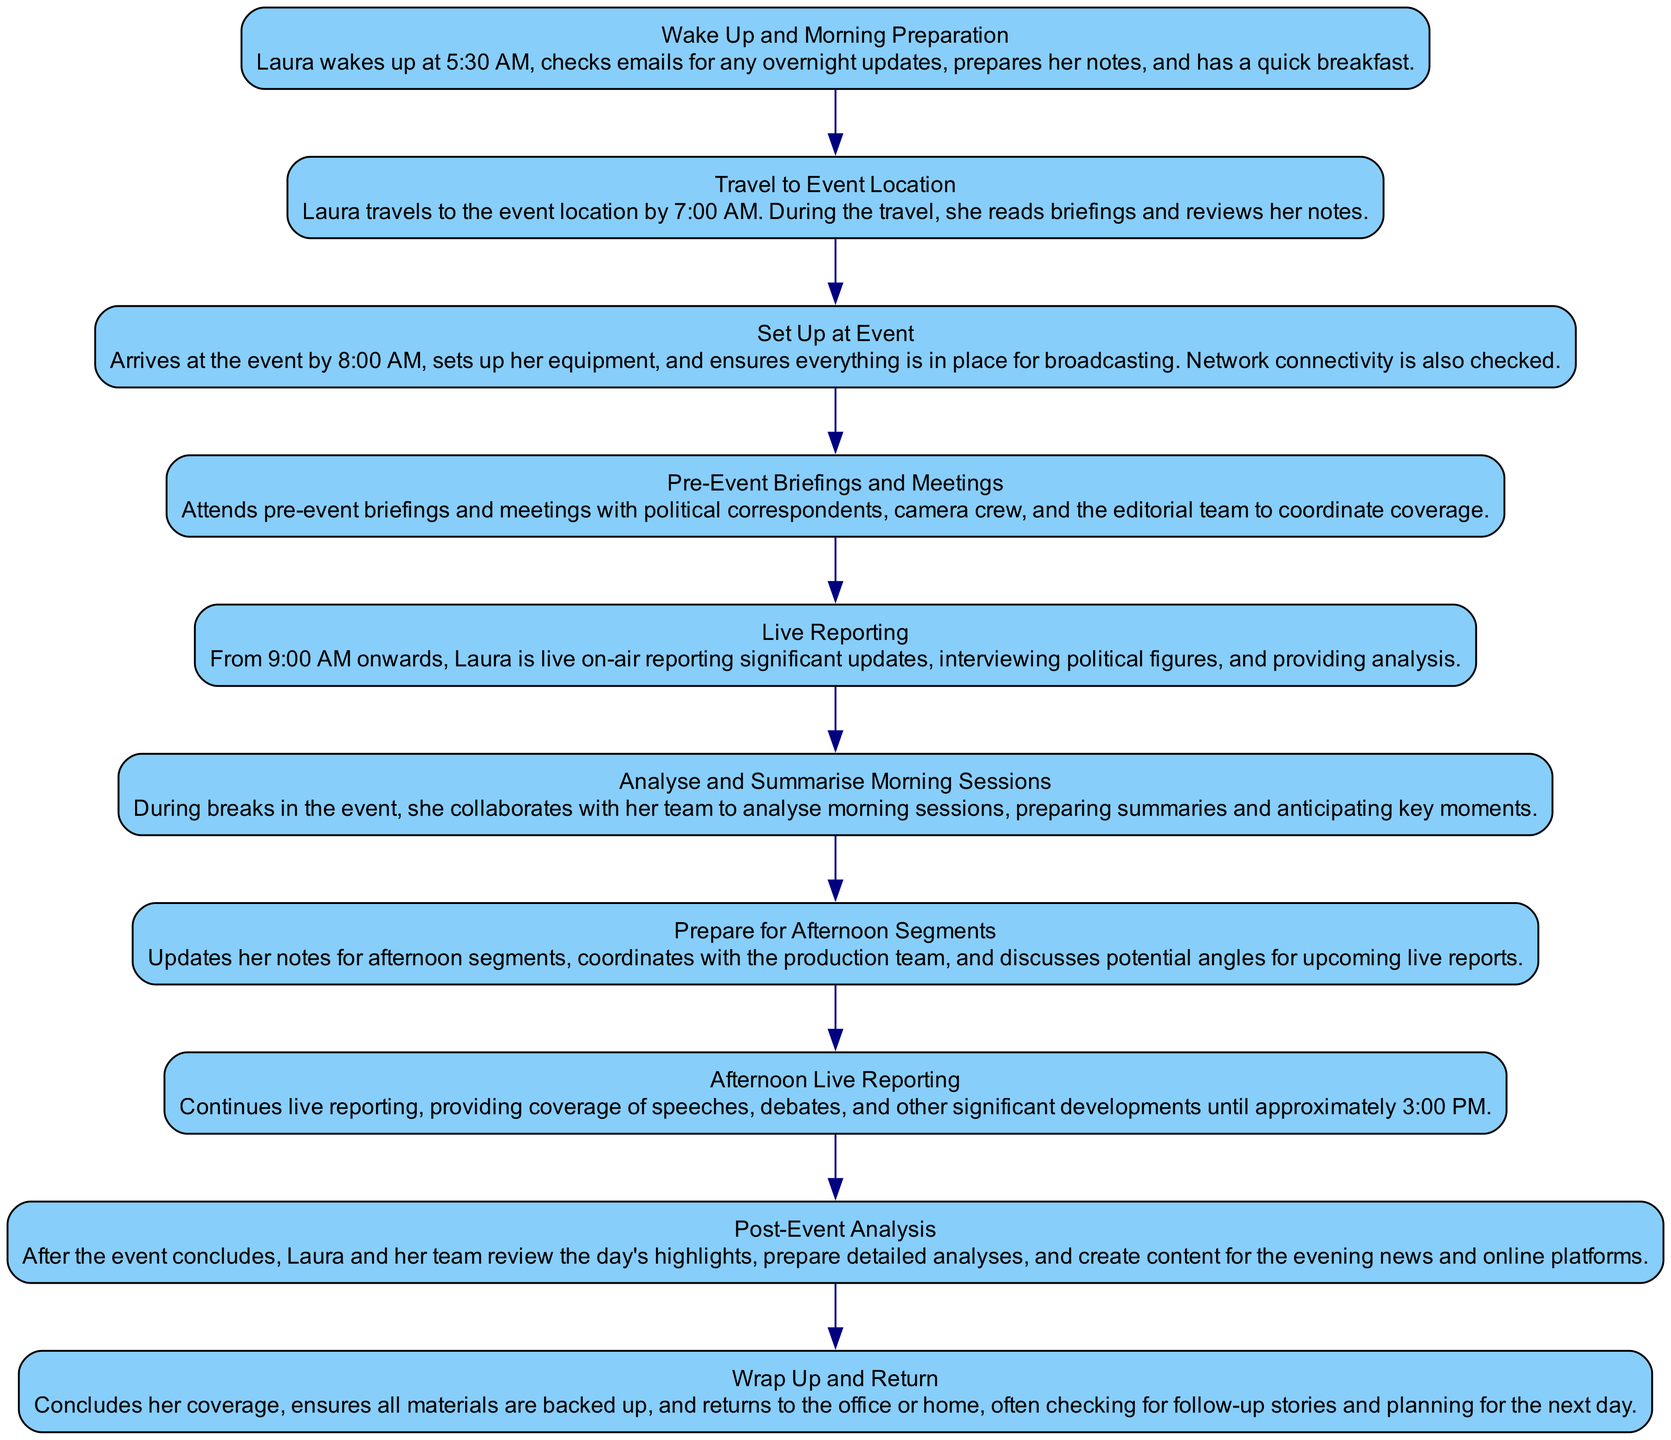What time does Laura wake up? The diagram indicates that Laura wakes up at 5:30 AM as part of her morning preparation.
Answer: 5:30 AM What is the first activity in the diagram? The diagram begins with the activity "Wake Up and Morning Preparation".
Answer: Wake Up and Morning Preparation How many activities are listed in the diagram? By counting the activities listed, we find there are ten activities detailed in the diagram.
Answer: 10 What activity follows "Pre-Event Briefings and Meetings"? According to the flow of the diagram, the activity that follows "Pre-Event Briefings and Meetings" is "Live Reporting".
Answer: Live Reporting During which time does Laura begin live reporting? The diagram specifies that Laura starts live reporting at 9:00 AM.
Answer: 9:00 AM What does Laura do during breaks in the event? The diagram indicates that during breaks, she collaborates with her team to analyze morning sessions and prepares summaries.
Answer: Analyze and Summarise Morning Sessions What is the last activity mentioned in the diagram? The final activity in the diagram is "Wrap Up and Return".
Answer: Wrap Up and Return How does Laura prepare for afternoon segments? The diagram describes that Laura updates her notes, coordinates with the production team, and discusses potential angles.
Answer: Updates her notes Which activity involves reviewing the day's highlights? According to the diagram, "Post-Event Analysis" involves reviewing the day's highlights.
Answer: Post-Event Analysis What is checked upon setting up at the event? The diagram mentions that during the setup, Laura checks network connectivity.
Answer: Network connectivity 